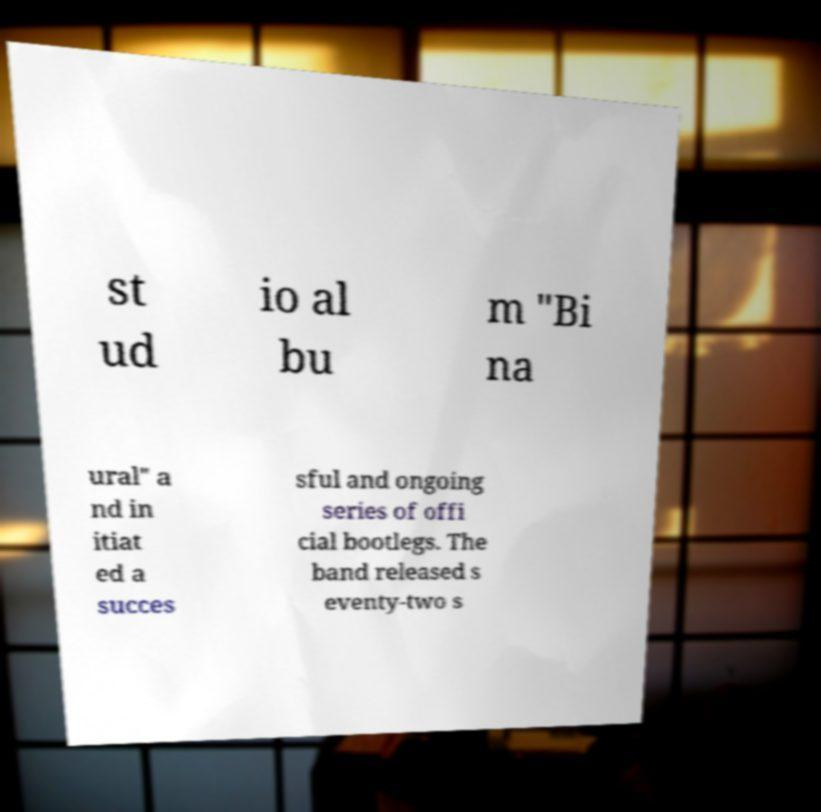Could you extract and type out the text from this image? st ud io al bu m "Bi na ural" a nd in itiat ed a succes sful and ongoing series of offi cial bootlegs. The band released s eventy-two s 